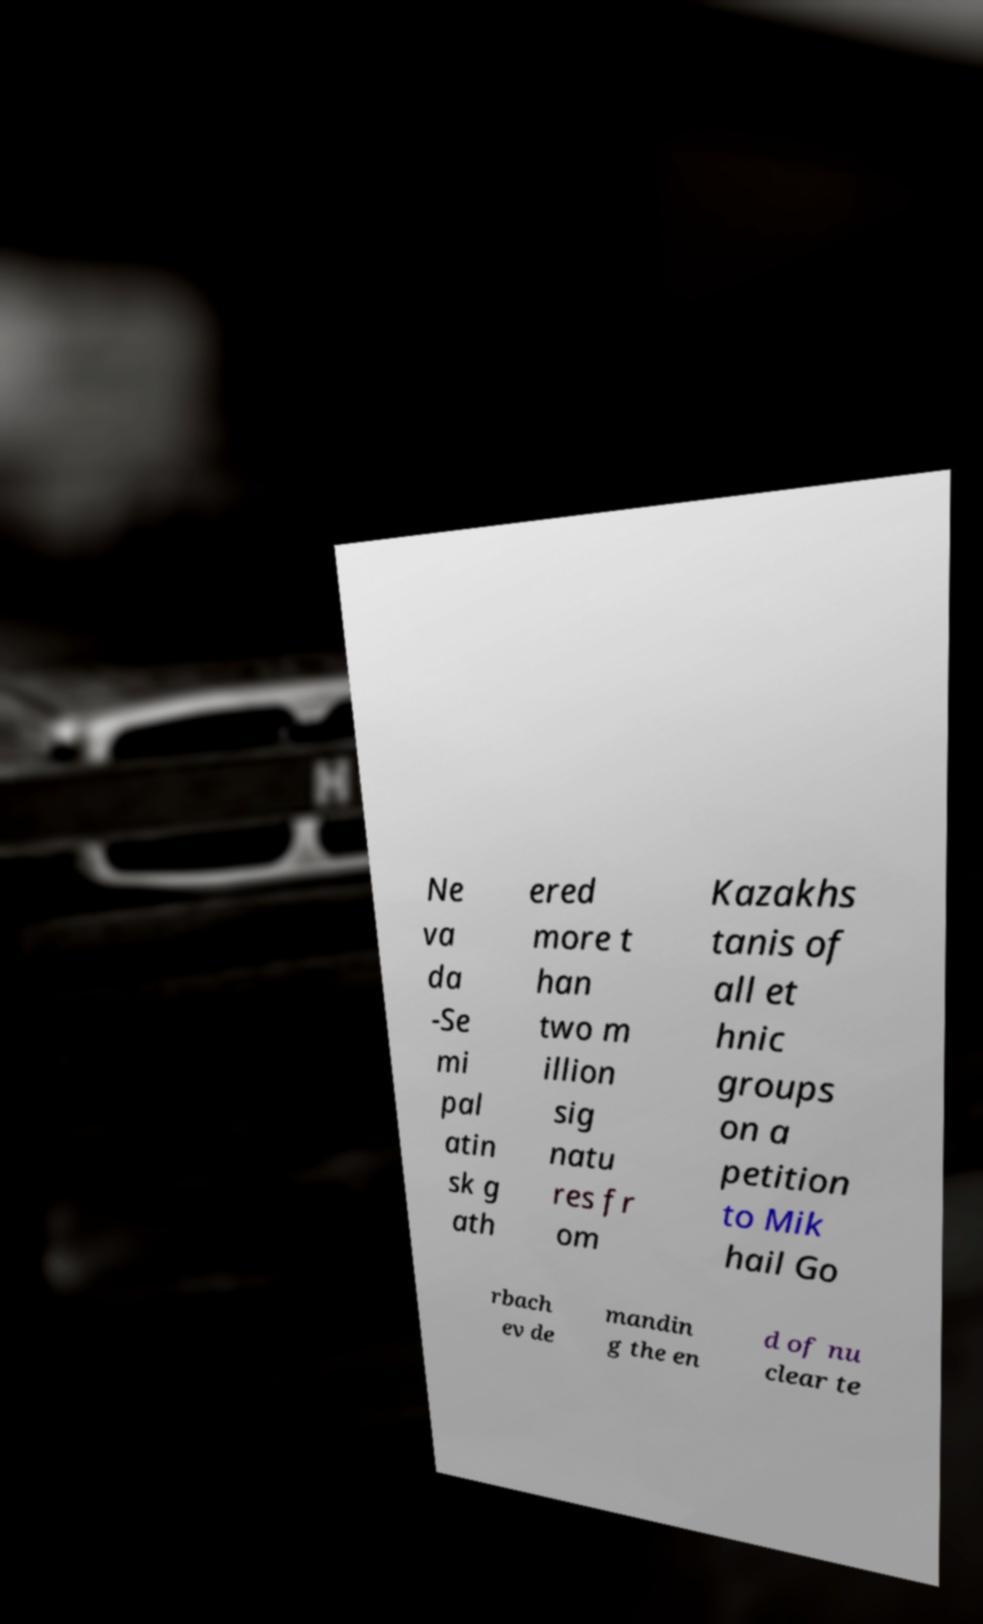For documentation purposes, I need the text within this image transcribed. Could you provide that? Ne va da -Se mi pal atin sk g ath ered more t han two m illion sig natu res fr om Kazakhs tanis of all et hnic groups on a petition to Mik hail Go rbach ev de mandin g the en d of nu clear te 